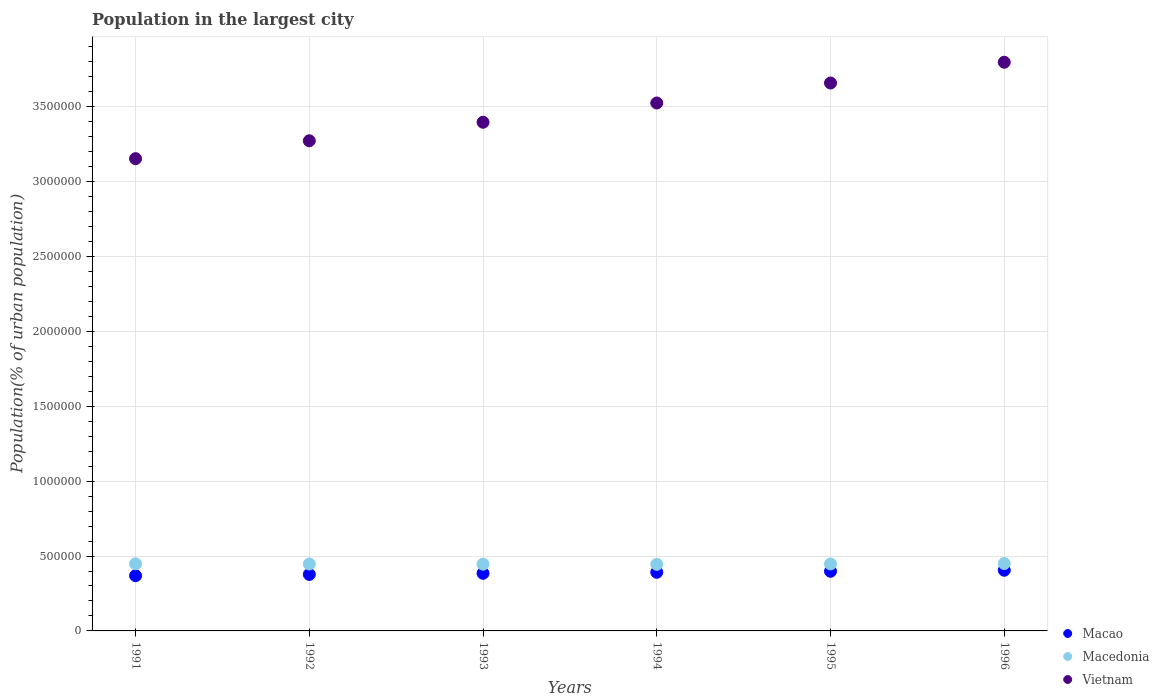What is the population in the largest city in Macao in 1993?
Offer a terse response. 3.85e+05. Across all years, what is the maximum population in the largest city in Macedonia?
Offer a terse response. 4.50e+05. Across all years, what is the minimum population in the largest city in Vietnam?
Keep it short and to the point. 3.15e+06. In which year was the population in the largest city in Macedonia maximum?
Provide a succinct answer. 1996. What is the total population in the largest city in Macedonia in the graph?
Offer a very short reply. 2.68e+06. What is the difference between the population in the largest city in Macao in 1992 and that in 1994?
Ensure brevity in your answer.  -1.42e+04. What is the difference between the population in the largest city in Vietnam in 1991 and the population in the largest city in Macao in 1996?
Offer a very short reply. 2.75e+06. What is the average population in the largest city in Vietnam per year?
Your answer should be compact. 3.47e+06. In the year 1991, what is the difference between the population in the largest city in Macao and population in the largest city in Vietnam?
Make the answer very short. -2.78e+06. What is the ratio of the population in the largest city in Vietnam in 1992 to that in 1994?
Your response must be concise. 0.93. What is the difference between the highest and the second highest population in the largest city in Vietnam?
Your answer should be very brief. 1.39e+05. What is the difference between the highest and the lowest population in the largest city in Macao?
Give a very brief answer. 3.64e+04. Is the sum of the population in the largest city in Vietnam in 1992 and 1994 greater than the maximum population in the largest city in Macao across all years?
Provide a succinct answer. Yes. Is the population in the largest city in Vietnam strictly less than the population in the largest city in Macedonia over the years?
Keep it short and to the point. No. Does the graph contain grids?
Your answer should be very brief. Yes. How are the legend labels stacked?
Give a very brief answer. Vertical. What is the title of the graph?
Give a very brief answer. Population in the largest city. What is the label or title of the Y-axis?
Give a very brief answer. Population(% of urban population). What is the Population(% of urban population) of Macao in 1991?
Offer a very short reply. 3.69e+05. What is the Population(% of urban population) of Macedonia in 1991?
Offer a terse response. 4.48e+05. What is the Population(% of urban population) of Vietnam in 1991?
Your response must be concise. 3.15e+06. What is the Population(% of urban population) in Macao in 1992?
Ensure brevity in your answer.  3.77e+05. What is the Population(% of urban population) of Macedonia in 1992?
Your answer should be compact. 4.47e+05. What is the Population(% of urban population) in Vietnam in 1992?
Offer a very short reply. 3.27e+06. What is the Population(% of urban population) of Macao in 1993?
Give a very brief answer. 3.85e+05. What is the Population(% of urban population) of Macedonia in 1993?
Your answer should be very brief. 4.45e+05. What is the Population(% of urban population) in Vietnam in 1993?
Your response must be concise. 3.40e+06. What is the Population(% of urban population) in Macao in 1994?
Offer a terse response. 3.91e+05. What is the Population(% of urban population) of Macedonia in 1994?
Ensure brevity in your answer.  4.44e+05. What is the Population(% of urban population) in Vietnam in 1994?
Your response must be concise. 3.52e+06. What is the Population(% of urban population) in Macao in 1995?
Your response must be concise. 3.98e+05. What is the Population(% of urban population) in Macedonia in 1995?
Give a very brief answer. 4.47e+05. What is the Population(% of urban population) in Vietnam in 1995?
Offer a terse response. 3.66e+06. What is the Population(% of urban population) in Macao in 1996?
Your answer should be compact. 4.05e+05. What is the Population(% of urban population) in Macedonia in 1996?
Provide a succinct answer. 4.50e+05. What is the Population(% of urban population) of Vietnam in 1996?
Provide a succinct answer. 3.80e+06. Across all years, what is the maximum Population(% of urban population) of Macao?
Keep it short and to the point. 4.05e+05. Across all years, what is the maximum Population(% of urban population) in Macedonia?
Offer a terse response. 4.50e+05. Across all years, what is the maximum Population(% of urban population) of Vietnam?
Your response must be concise. 3.80e+06. Across all years, what is the minimum Population(% of urban population) of Macao?
Provide a succinct answer. 3.69e+05. Across all years, what is the minimum Population(% of urban population) in Macedonia?
Ensure brevity in your answer.  4.44e+05. Across all years, what is the minimum Population(% of urban population) of Vietnam?
Give a very brief answer. 3.15e+06. What is the total Population(% of urban population) of Macao in the graph?
Provide a succinct answer. 2.33e+06. What is the total Population(% of urban population) in Macedonia in the graph?
Offer a terse response. 2.68e+06. What is the total Population(% of urban population) of Vietnam in the graph?
Give a very brief answer. 2.08e+07. What is the difference between the Population(% of urban population) of Macao in 1991 and that in 1992?
Your answer should be very brief. -8429. What is the difference between the Population(% of urban population) of Macedonia in 1991 and that in 1992?
Your answer should be very brief. 1224. What is the difference between the Population(% of urban population) in Vietnam in 1991 and that in 1992?
Your answer should be very brief. -1.19e+05. What is the difference between the Population(% of urban population) of Macao in 1991 and that in 1993?
Provide a succinct answer. -1.58e+04. What is the difference between the Population(% of urban population) in Macedonia in 1991 and that in 1993?
Keep it short and to the point. 2442. What is the difference between the Population(% of urban population) of Vietnam in 1991 and that in 1993?
Ensure brevity in your answer.  -2.43e+05. What is the difference between the Population(% of urban population) of Macao in 1991 and that in 1994?
Your answer should be very brief. -2.26e+04. What is the difference between the Population(% of urban population) of Macedonia in 1991 and that in 1994?
Make the answer very short. 3540. What is the difference between the Population(% of urban population) in Vietnam in 1991 and that in 1994?
Offer a terse response. -3.72e+05. What is the difference between the Population(% of urban population) of Macao in 1991 and that in 1995?
Offer a terse response. -2.93e+04. What is the difference between the Population(% of urban population) of Macedonia in 1991 and that in 1995?
Ensure brevity in your answer.  854. What is the difference between the Population(% of urban population) in Vietnam in 1991 and that in 1995?
Provide a succinct answer. -5.05e+05. What is the difference between the Population(% of urban population) in Macao in 1991 and that in 1996?
Offer a terse response. -3.64e+04. What is the difference between the Population(% of urban population) in Macedonia in 1991 and that in 1996?
Your response must be concise. -1851. What is the difference between the Population(% of urban population) of Vietnam in 1991 and that in 1996?
Your answer should be compact. -6.44e+05. What is the difference between the Population(% of urban population) in Macao in 1992 and that in 1993?
Make the answer very short. -7339. What is the difference between the Population(% of urban population) in Macedonia in 1992 and that in 1993?
Make the answer very short. 1218. What is the difference between the Population(% of urban population) in Vietnam in 1992 and that in 1993?
Give a very brief answer. -1.24e+05. What is the difference between the Population(% of urban population) in Macao in 1992 and that in 1994?
Your response must be concise. -1.42e+04. What is the difference between the Population(% of urban population) of Macedonia in 1992 and that in 1994?
Make the answer very short. 2316. What is the difference between the Population(% of urban population) in Vietnam in 1992 and that in 1994?
Offer a very short reply. -2.52e+05. What is the difference between the Population(% of urban population) in Macao in 1992 and that in 1995?
Provide a short and direct response. -2.09e+04. What is the difference between the Population(% of urban population) of Macedonia in 1992 and that in 1995?
Your answer should be very brief. -370. What is the difference between the Population(% of urban population) in Vietnam in 1992 and that in 1995?
Offer a very short reply. -3.86e+05. What is the difference between the Population(% of urban population) of Macao in 1992 and that in 1996?
Offer a terse response. -2.80e+04. What is the difference between the Population(% of urban population) of Macedonia in 1992 and that in 1996?
Provide a succinct answer. -3075. What is the difference between the Population(% of urban population) in Vietnam in 1992 and that in 1996?
Keep it short and to the point. -5.24e+05. What is the difference between the Population(% of urban population) in Macao in 1993 and that in 1994?
Your answer should be compact. -6825. What is the difference between the Population(% of urban population) in Macedonia in 1993 and that in 1994?
Offer a very short reply. 1098. What is the difference between the Population(% of urban population) in Vietnam in 1993 and that in 1994?
Keep it short and to the point. -1.29e+05. What is the difference between the Population(% of urban population) of Macao in 1993 and that in 1995?
Give a very brief answer. -1.36e+04. What is the difference between the Population(% of urban population) in Macedonia in 1993 and that in 1995?
Provide a short and direct response. -1588. What is the difference between the Population(% of urban population) of Vietnam in 1993 and that in 1995?
Your answer should be compact. -2.62e+05. What is the difference between the Population(% of urban population) of Macao in 1993 and that in 1996?
Provide a short and direct response. -2.06e+04. What is the difference between the Population(% of urban population) in Macedonia in 1993 and that in 1996?
Provide a short and direct response. -4293. What is the difference between the Population(% of urban population) in Vietnam in 1993 and that in 1996?
Your answer should be very brief. -4.01e+05. What is the difference between the Population(% of urban population) in Macao in 1994 and that in 1995?
Offer a very short reply. -6745. What is the difference between the Population(% of urban population) of Macedonia in 1994 and that in 1995?
Your answer should be compact. -2686. What is the difference between the Population(% of urban population) of Vietnam in 1994 and that in 1995?
Ensure brevity in your answer.  -1.33e+05. What is the difference between the Population(% of urban population) of Macao in 1994 and that in 1996?
Offer a very short reply. -1.38e+04. What is the difference between the Population(% of urban population) in Macedonia in 1994 and that in 1996?
Your answer should be very brief. -5391. What is the difference between the Population(% of urban population) of Vietnam in 1994 and that in 1996?
Provide a short and direct response. -2.72e+05. What is the difference between the Population(% of urban population) of Macao in 1995 and that in 1996?
Ensure brevity in your answer.  -7048. What is the difference between the Population(% of urban population) of Macedonia in 1995 and that in 1996?
Your response must be concise. -2705. What is the difference between the Population(% of urban population) in Vietnam in 1995 and that in 1996?
Provide a succinct answer. -1.39e+05. What is the difference between the Population(% of urban population) in Macao in 1991 and the Population(% of urban population) in Macedonia in 1992?
Your answer should be very brief. -7.79e+04. What is the difference between the Population(% of urban population) in Macao in 1991 and the Population(% of urban population) in Vietnam in 1992?
Provide a short and direct response. -2.90e+06. What is the difference between the Population(% of urban population) of Macedonia in 1991 and the Population(% of urban population) of Vietnam in 1992?
Your response must be concise. -2.82e+06. What is the difference between the Population(% of urban population) of Macao in 1991 and the Population(% of urban population) of Macedonia in 1993?
Your answer should be compact. -7.67e+04. What is the difference between the Population(% of urban population) of Macao in 1991 and the Population(% of urban population) of Vietnam in 1993?
Provide a succinct answer. -3.03e+06. What is the difference between the Population(% of urban population) of Macedonia in 1991 and the Population(% of urban population) of Vietnam in 1993?
Your response must be concise. -2.95e+06. What is the difference between the Population(% of urban population) of Macao in 1991 and the Population(% of urban population) of Macedonia in 1994?
Offer a very short reply. -7.56e+04. What is the difference between the Population(% of urban population) in Macao in 1991 and the Population(% of urban population) in Vietnam in 1994?
Offer a terse response. -3.16e+06. What is the difference between the Population(% of urban population) in Macedonia in 1991 and the Population(% of urban population) in Vietnam in 1994?
Your answer should be compact. -3.08e+06. What is the difference between the Population(% of urban population) of Macao in 1991 and the Population(% of urban population) of Macedonia in 1995?
Offer a terse response. -7.83e+04. What is the difference between the Population(% of urban population) of Macao in 1991 and the Population(% of urban population) of Vietnam in 1995?
Provide a short and direct response. -3.29e+06. What is the difference between the Population(% of urban population) in Macedonia in 1991 and the Population(% of urban population) in Vietnam in 1995?
Ensure brevity in your answer.  -3.21e+06. What is the difference between the Population(% of urban population) in Macao in 1991 and the Population(% of urban population) in Macedonia in 1996?
Your answer should be very brief. -8.10e+04. What is the difference between the Population(% of urban population) in Macao in 1991 and the Population(% of urban population) in Vietnam in 1996?
Offer a very short reply. -3.43e+06. What is the difference between the Population(% of urban population) of Macedonia in 1991 and the Population(% of urban population) of Vietnam in 1996?
Offer a very short reply. -3.35e+06. What is the difference between the Population(% of urban population) of Macao in 1992 and the Population(% of urban population) of Macedonia in 1993?
Your answer should be very brief. -6.83e+04. What is the difference between the Population(% of urban population) of Macao in 1992 and the Population(% of urban population) of Vietnam in 1993?
Make the answer very short. -3.02e+06. What is the difference between the Population(% of urban population) of Macedonia in 1992 and the Population(% of urban population) of Vietnam in 1993?
Provide a succinct answer. -2.95e+06. What is the difference between the Population(% of urban population) of Macao in 1992 and the Population(% of urban population) of Macedonia in 1994?
Provide a succinct answer. -6.72e+04. What is the difference between the Population(% of urban population) in Macao in 1992 and the Population(% of urban population) in Vietnam in 1994?
Give a very brief answer. -3.15e+06. What is the difference between the Population(% of urban population) in Macedonia in 1992 and the Population(% of urban population) in Vietnam in 1994?
Your answer should be very brief. -3.08e+06. What is the difference between the Population(% of urban population) in Macao in 1992 and the Population(% of urban population) in Macedonia in 1995?
Give a very brief answer. -6.99e+04. What is the difference between the Population(% of urban population) in Macao in 1992 and the Population(% of urban population) in Vietnam in 1995?
Provide a short and direct response. -3.28e+06. What is the difference between the Population(% of urban population) in Macedonia in 1992 and the Population(% of urban population) in Vietnam in 1995?
Your answer should be very brief. -3.21e+06. What is the difference between the Population(% of urban population) of Macao in 1992 and the Population(% of urban population) of Macedonia in 1996?
Your answer should be very brief. -7.26e+04. What is the difference between the Population(% of urban population) in Macao in 1992 and the Population(% of urban population) in Vietnam in 1996?
Provide a short and direct response. -3.42e+06. What is the difference between the Population(% of urban population) of Macedonia in 1992 and the Population(% of urban population) of Vietnam in 1996?
Offer a very short reply. -3.35e+06. What is the difference between the Population(% of urban population) in Macao in 1993 and the Population(% of urban population) in Macedonia in 1994?
Ensure brevity in your answer.  -5.98e+04. What is the difference between the Population(% of urban population) in Macao in 1993 and the Population(% of urban population) in Vietnam in 1994?
Ensure brevity in your answer.  -3.14e+06. What is the difference between the Population(% of urban population) in Macedonia in 1993 and the Population(% of urban population) in Vietnam in 1994?
Keep it short and to the point. -3.08e+06. What is the difference between the Population(% of urban population) in Macao in 1993 and the Population(% of urban population) in Macedonia in 1995?
Your answer should be compact. -6.25e+04. What is the difference between the Population(% of urban population) in Macao in 1993 and the Population(% of urban population) in Vietnam in 1995?
Offer a very short reply. -3.27e+06. What is the difference between the Population(% of urban population) in Macedonia in 1993 and the Population(% of urban population) in Vietnam in 1995?
Offer a very short reply. -3.21e+06. What is the difference between the Population(% of urban population) in Macao in 1993 and the Population(% of urban population) in Macedonia in 1996?
Your answer should be compact. -6.52e+04. What is the difference between the Population(% of urban population) in Macao in 1993 and the Population(% of urban population) in Vietnam in 1996?
Give a very brief answer. -3.41e+06. What is the difference between the Population(% of urban population) of Macedonia in 1993 and the Population(% of urban population) of Vietnam in 1996?
Offer a very short reply. -3.35e+06. What is the difference between the Population(% of urban population) of Macao in 1994 and the Population(% of urban population) of Macedonia in 1995?
Give a very brief answer. -5.57e+04. What is the difference between the Population(% of urban population) in Macao in 1994 and the Population(% of urban population) in Vietnam in 1995?
Provide a short and direct response. -3.27e+06. What is the difference between the Population(% of urban population) in Macedonia in 1994 and the Population(% of urban population) in Vietnam in 1995?
Your answer should be compact. -3.21e+06. What is the difference between the Population(% of urban population) of Macao in 1994 and the Population(% of urban population) of Macedonia in 1996?
Offer a very short reply. -5.84e+04. What is the difference between the Population(% of urban population) of Macao in 1994 and the Population(% of urban population) of Vietnam in 1996?
Give a very brief answer. -3.41e+06. What is the difference between the Population(% of urban population) in Macedonia in 1994 and the Population(% of urban population) in Vietnam in 1996?
Make the answer very short. -3.35e+06. What is the difference between the Population(% of urban population) of Macao in 1995 and the Population(% of urban population) of Macedonia in 1996?
Give a very brief answer. -5.17e+04. What is the difference between the Population(% of urban population) of Macao in 1995 and the Population(% of urban population) of Vietnam in 1996?
Offer a very short reply. -3.40e+06. What is the difference between the Population(% of urban population) in Macedonia in 1995 and the Population(% of urban population) in Vietnam in 1996?
Offer a terse response. -3.35e+06. What is the average Population(% of urban population) of Macao per year?
Provide a succinct answer. 3.88e+05. What is the average Population(% of urban population) in Macedonia per year?
Ensure brevity in your answer.  4.47e+05. What is the average Population(% of urban population) in Vietnam per year?
Your answer should be compact. 3.47e+06. In the year 1991, what is the difference between the Population(% of urban population) in Macao and Population(% of urban population) in Macedonia?
Keep it short and to the point. -7.92e+04. In the year 1991, what is the difference between the Population(% of urban population) of Macao and Population(% of urban population) of Vietnam?
Provide a succinct answer. -2.78e+06. In the year 1991, what is the difference between the Population(% of urban population) of Macedonia and Population(% of urban population) of Vietnam?
Provide a short and direct response. -2.70e+06. In the year 1992, what is the difference between the Population(% of urban population) of Macao and Population(% of urban population) of Macedonia?
Ensure brevity in your answer.  -6.95e+04. In the year 1992, what is the difference between the Population(% of urban population) of Macao and Population(% of urban population) of Vietnam?
Offer a very short reply. -2.90e+06. In the year 1992, what is the difference between the Population(% of urban population) in Macedonia and Population(% of urban population) in Vietnam?
Ensure brevity in your answer.  -2.83e+06. In the year 1993, what is the difference between the Population(% of urban population) of Macao and Population(% of urban population) of Macedonia?
Keep it short and to the point. -6.09e+04. In the year 1993, what is the difference between the Population(% of urban population) in Macao and Population(% of urban population) in Vietnam?
Your response must be concise. -3.01e+06. In the year 1993, what is the difference between the Population(% of urban population) in Macedonia and Population(% of urban population) in Vietnam?
Ensure brevity in your answer.  -2.95e+06. In the year 1994, what is the difference between the Population(% of urban population) in Macao and Population(% of urban population) in Macedonia?
Your response must be concise. -5.30e+04. In the year 1994, what is the difference between the Population(% of urban population) of Macao and Population(% of urban population) of Vietnam?
Make the answer very short. -3.13e+06. In the year 1994, what is the difference between the Population(% of urban population) in Macedonia and Population(% of urban population) in Vietnam?
Offer a very short reply. -3.08e+06. In the year 1995, what is the difference between the Population(% of urban population) in Macao and Population(% of urban population) in Macedonia?
Your response must be concise. -4.90e+04. In the year 1995, what is the difference between the Population(% of urban population) in Macao and Population(% of urban population) in Vietnam?
Provide a short and direct response. -3.26e+06. In the year 1995, what is the difference between the Population(% of urban population) in Macedonia and Population(% of urban population) in Vietnam?
Ensure brevity in your answer.  -3.21e+06. In the year 1996, what is the difference between the Population(% of urban population) of Macao and Population(% of urban population) of Macedonia?
Make the answer very short. -4.46e+04. In the year 1996, what is the difference between the Population(% of urban population) of Macao and Population(% of urban population) of Vietnam?
Give a very brief answer. -3.39e+06. In the year 1996, what is the difference between the Population(% of urban population) in Macedonia and Population(% of urban population) in Vietnam?
Your answer should be very brief. -3.35e+06. What is the ratio of the Population(% of urban population) in Macao in 1991 to that in 1992?
Your response must be concise. 0.98. What is the ratio of the Population(% of urban population) in Macedonia in 1991 to that in 1992?
Provide a succinct answer. 1. What is the ratio of the Population(% of urban population) of Vietnam in 1991 to that in 1992?
Your answer should be very brief. 0.96. What is the ratio of the Population(% of urban population) in Vietnam in 1991 to that in 1993?
Your response must be concise. 0.93. What is the ratio of the Population(% of urban population) of Macao in 1991 to that in 1994?
Provide a short and direct response. 0.94. What is the ratio of the Population(% of urban population) in Macedonia in 1991 to that in 1994?
Your answer should be compact. 1.01. What is the ratio of the Population(% of urban population) in Vietnam in 1991 to that in 1994?
Provide a short and direct response. 0.89. What is the ratio of the Population(% of urban population) in Macao in 1991 to that in 1995?
Provide a succinct answer. 0.93. What is the ratio of the Population(% of urban population) of Macedonia in 1991 to that in 1995?
Offer a terse response. 1. What is the ratio of the Population(% of urban population) of Vietnam in 1991 to that in 1995?
Give a very brief answer. 0.86. What is the ratio of the Population(% of urban population) in Macao in 1991 to that in 1996?
Your response must be concise. 0.91. What is the ratio of the Population(% of urban population) of Macedonia in 1991 to that in 1996?
Offer a terse response. 1. What is the ratio of the Population(% of urban population) in Vietnam in 1991 to that in 1996?
Make the answer very short. 0.83. What is the ratio of the Population(% of urban population) of Macao in 1992 to that in 1993?
Keep it short and to the point. 0.98. What is the ratio of the Population(% of urban population) of Macedonia in 1992 to that in 1993?
Ensure brevity in your answer.  1. What is the ratio of the Population(% of urban population) in Vietnam in 1992 to that in 1993?
Keep it short and to the point. 0.96. What is the ratio of the Population(% of urban population) in Macao in 1992 to that in 1994?
Your answer should be very brief. 0.96. What is the ratio of the Population(% of urban population) in Macedonia in 1992 to that in 1994?
Make the answer very short. 1.01. What is the ratio of the Population(% of urban population) in Vietnam in 1992 to that in 1994?
Give a very brief answer. 0.93. What is the ratio of the Population(% of urban population) in Macao in 1992 to that in 1995?
Your answer should be very brief. 0.95. What is the ratio of the Population(% of urban population) in Vietnam in 1992 to that in 1995?
Provide a short and direct response. 0.89. What is the ratio of the Population(% of urban population) of Vietnam in 1992 to that in 1996?
Keep it short and to the point. 0.86. What is the ratio of the Population(% of urban population) of Macao in 1993 to that in 1994?
Your response must be concise. 0.98. What is the ratio of the Population(% of urban population) of Macedonia in 1993 to that in 1994?
Offer a terse response. 1. What is the ratio of the Population(% of urban population) in Vietnam in 1993 to that in 1994?
Your response must be concise. 0.96. What is the ratio of the Population(% of urban population) in Macao in 1993 to that in 1995?
Offer a very short reply. 0.97. What is the ratio of the Population(% of urban population) in Vietnam in 1993 to that in 1995?
Provide a succinct answer. 0.93. What is the ratio of the Population(% of urban population) of Macao in 1993 to that in 1996?
Give a very brief answer. 0.95. What is the ratio of the Population(% of urban population) in Macedonia in 1993 to that in 1996?
Your answer should be very brief. 0.99. What is the ratio of the Population(% of urban population) in Vietnam in 1993 to that in 1996?
Provide a succinct answer. 0.89. What is the ratio of the Population(% of urban population) in Macao in 1994 to that in 1995?
Ensure brevity in your answer.  0.98. What is the ratio of the Population(% of urban population) of Vietnam in 1994 to that in 1995?
Ensure brevity in your answer.  0.96. What is the ratio of the Population(% of urban population) in Macao in 1994 to that in 1996?
Your response must be concise. 0.97. What is the ratio of the Population(% of urban population) of Macedonia in 1994 to that in 1996?
Give a very brief answer. 0.99. What is the ratio of the Population(% of urban population) in Vietnam in 1994 to that in 1996?
Your response must be concise. 0.93. What is the ratio of the Population(% of urban population) in Macao in 1995 to that in 1996?
Your answer should be very brief. 0.98. What is the ratio of the Population(% of urban population) in Macedonia in 1995 to that in 1996?
Provide a succinct answer. 0.99. What is the ratio of the Population(% of urban population) in Vietnam in 1995 to that in 1996?
Make the answer very short. 0.96. What is the difference between the highest and the second highest Population(% of urban population) in Macao?
Ensure brevity in your answer.  7048. What is the difference between the highest and the second highest Population(% of urban population) in Macedonia?
Your answer should be compact. 1851. What is the difference between the highest and the second highest Population(% of urban population) of Vietnam?
Your answer should be very brief. 1.39e+05. What is the difference between the highest and the lowest Population(% of urban population) in Macao?
Offer a terse response. 3.64e+04. What is the difference between the highest and the lowest Population(% of urban population) of Macedonia?
Keep it short and to the point. 5391. What is the difference between the highest and the lowest Population(% of urban population) in Vietnam?
Offer a terse response. 6.44e+05. 